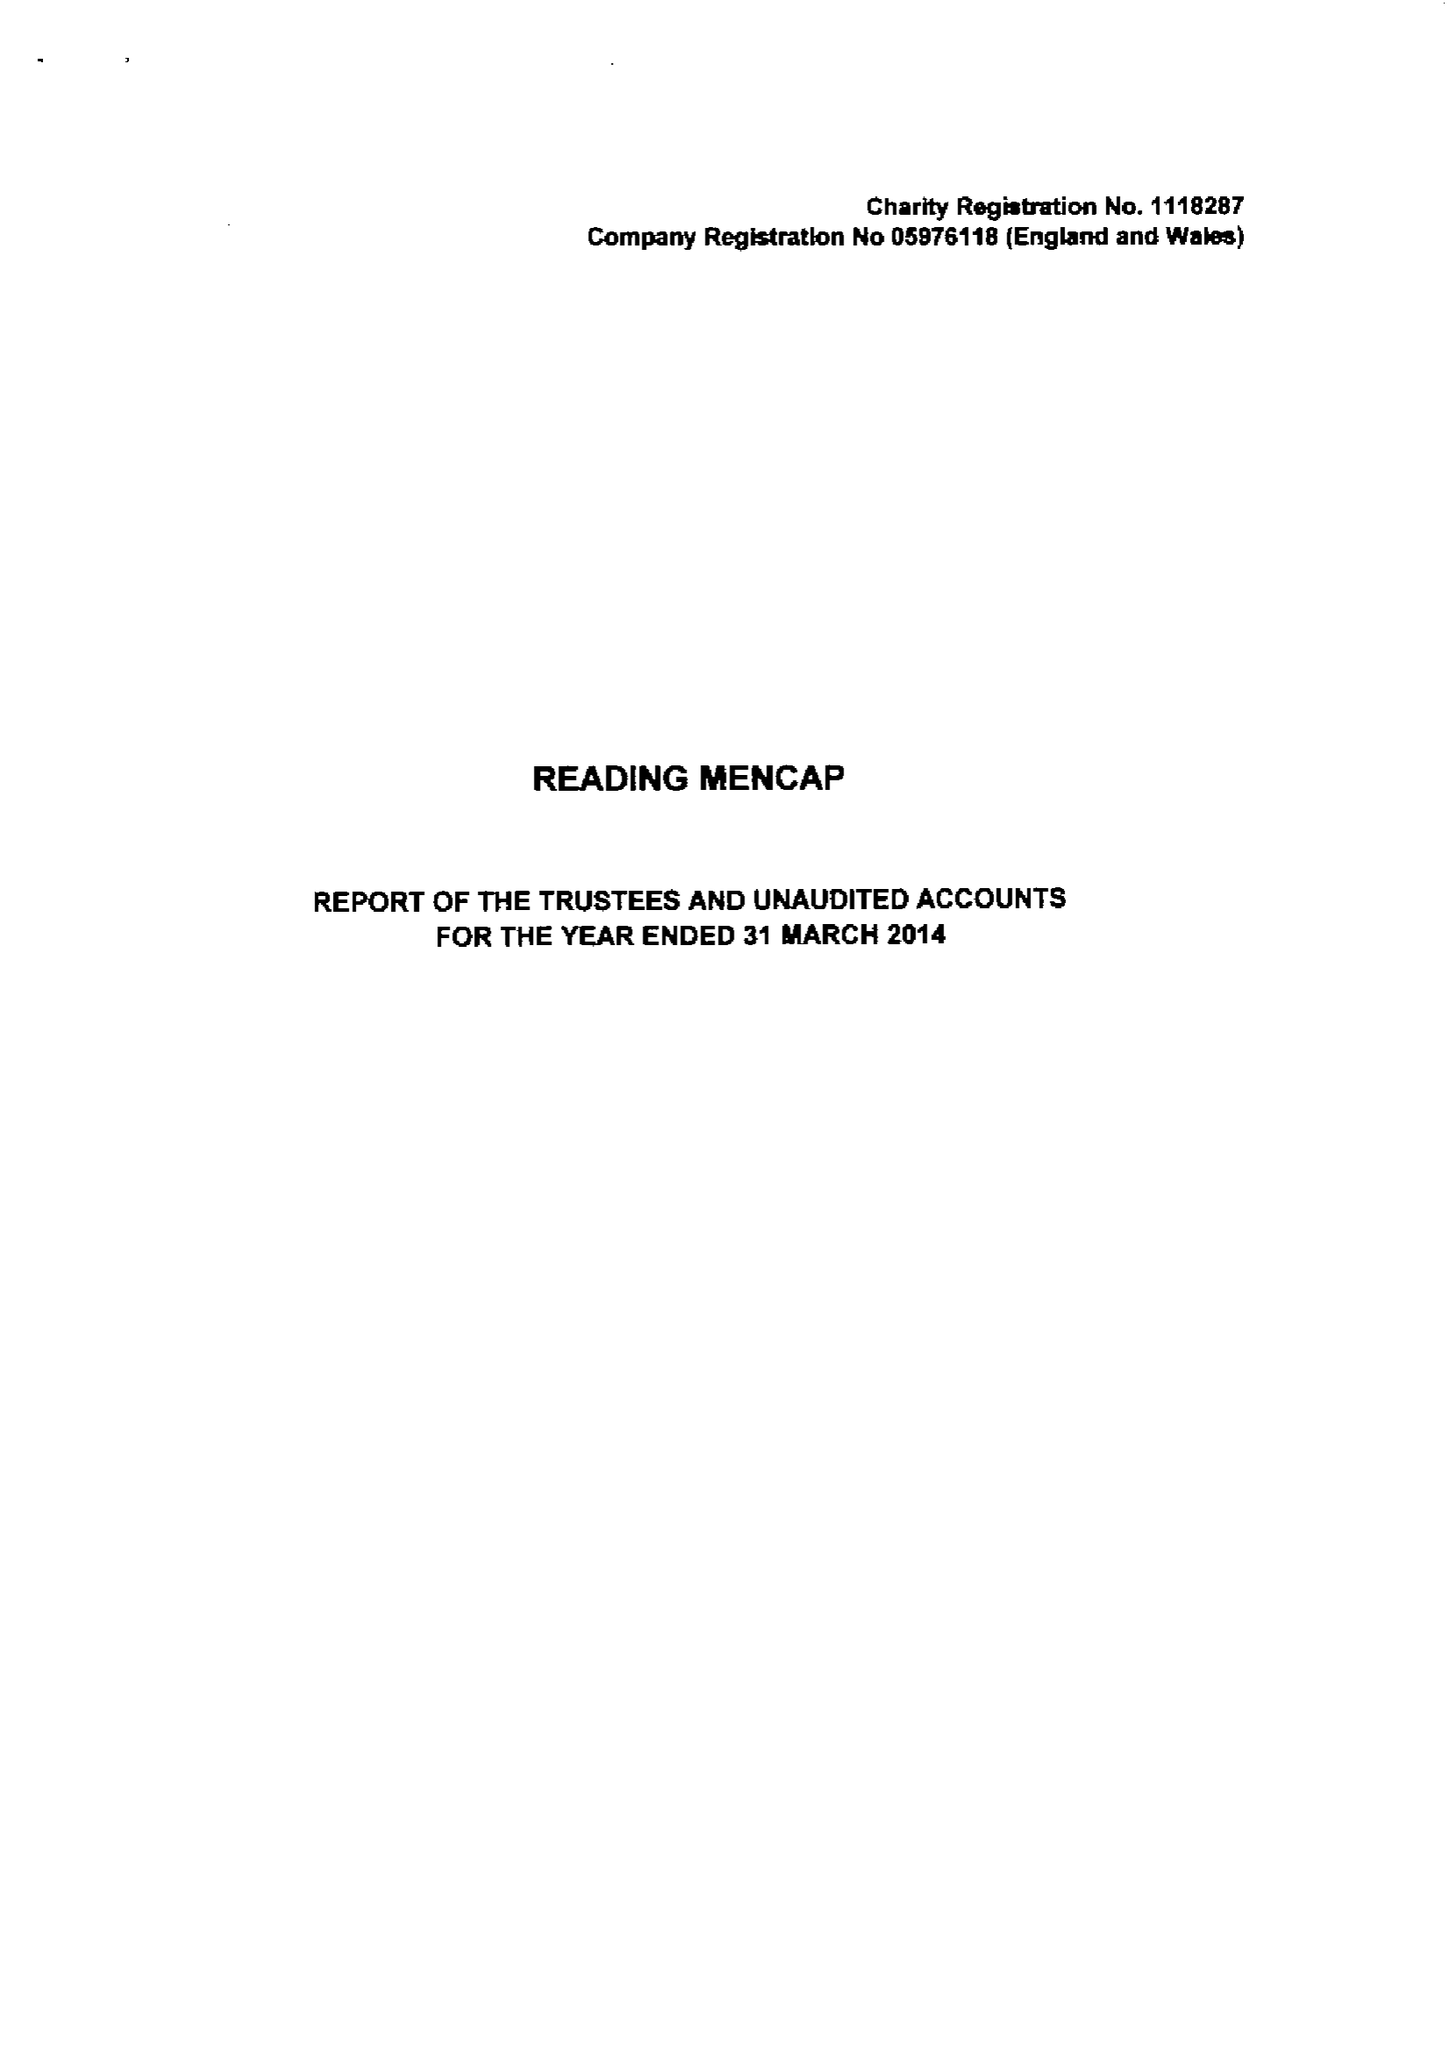What is the value for the report_date?
Answer the question using a single word or phrase. 2014-03-31 